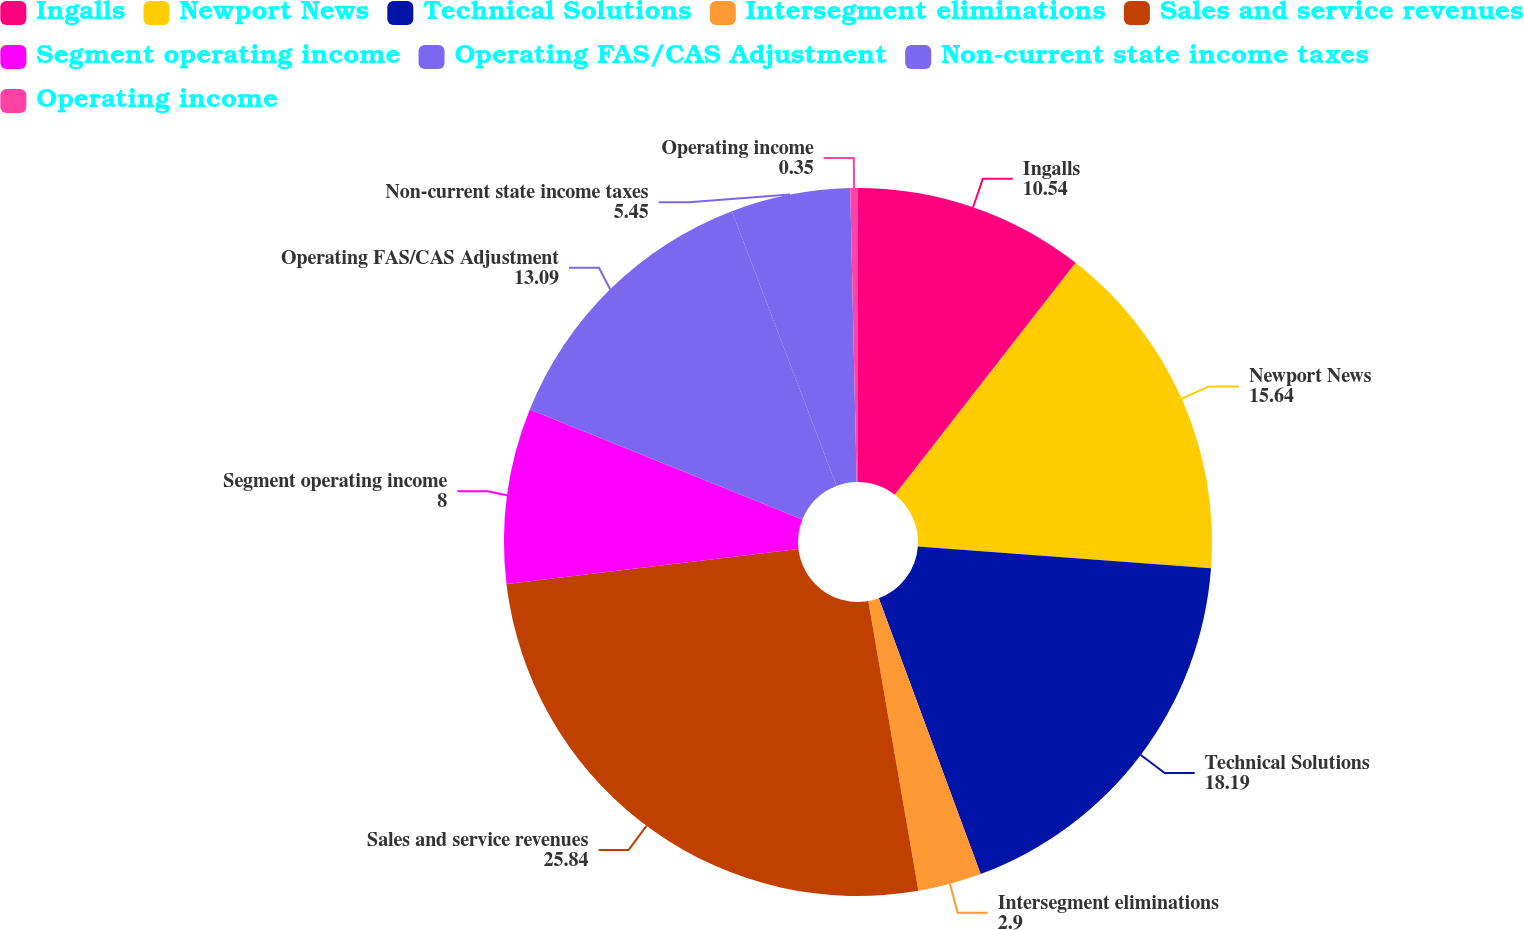Convert chart to OTSL. <chart><loc_0><loc_0><loc_500><loc_500><pie_chart><fcel>Ingalls<fcel>Newport News<fcel>Technical Solutions<fcel>Intersegment eliminations<fcel>Sales and service revenues<fcel>Segment operating income<fcel>Operating FAS/CAS Adjustment<fcel>Non-current state income taxes<fcel>Operating income<nl><fcel>10.54%<fcel>15.64%<fcel>18.19%<fcel>2.9%<fcel>25.84%<fcel>8.0%<fcel>13.09%<fcel>5.45%<fcel>0.35%<nl></chart> 